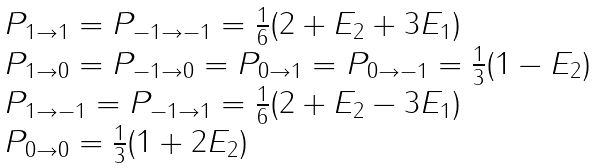<formula> <loc_0><loc_0><loc_500><loc_500>\begin{array} { l } P _ { 1 \rightarrow 1 } = P _ { - 1 \rightarrow - 1 } = \frac { 1 } { 6 } ( 2 + E _ { 2 } + 3 E _ { 1 } ) \\ P _ { 1 \rightarrow 0 } = P _ { - 1 \rightarrow 0 } = P _ { 0 \rightarrow 1 } = P _ { 0 \rightarrow - 1 } = \frac { 1 } { 3 } ( 1 - E _ { 2 } ) \\ P _ { 1 \rightarrow - 1 } = P _ { - 1 \rightarrow 1 } = \frac { 1 } { 6 } ( 2 + E _ { 2 } - 3 E _ { 1 } ) \\ P _ { 0 \rightarrow 0 } = \frac { 1 } { 3 } ( 1 + 2 E _ { 2 } ) \end{array}</formula> 